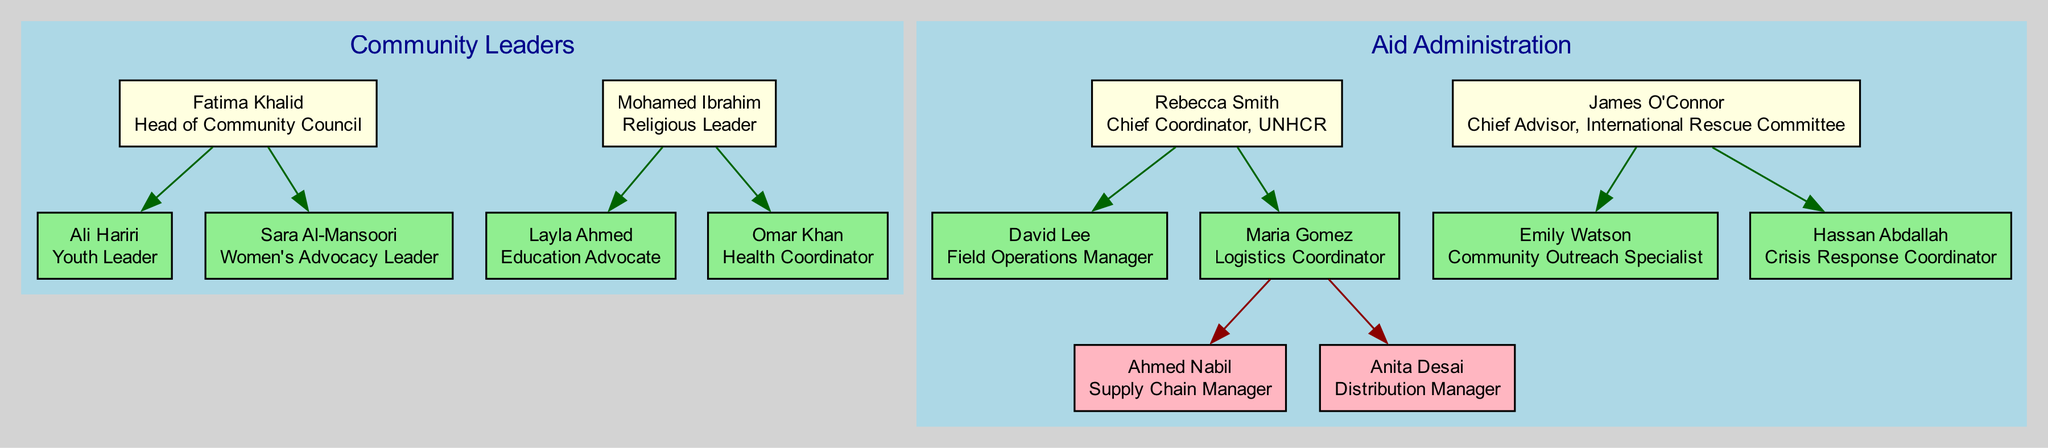What is the role of Fatima Khalid? According to the diagram, Fatima Khalid is identified as the "Head of Community Council." This is confirmed by locating her node, which contains her name and associated role.
Answer: Head of Community Council Who is the child of Mohamed Ibrahim? In the diagram, Mohamed Ibrahim has two direct subordinates indicated as his children: Layla Ahmed and Omar Khan. Any of these can be considered valid. Here, we can select one of the names as the answer.
Answer: Layla Ahmed How many grandchildren does Rebecca Smith have? The diagram indicates that Rebecca Smith has a direct subordinate, Maria Gomez, who has two subordinates: Ahmed Nabil and Anita Desai. Thus, Rebecca Smith has two grandchildren.
Answer: 2 Which community leader focuses on women's advocacy? From the diagram, Sara Al-Mansoori is specifically noted as the "Women's Advocacy Leader." Her node clearly states her focus.
Answer: Sara Al-Mansoori What is the relation between Ali Hariri and Fatima Khalid? The diagram shows that Ali Hariri is a direct child of Fatima Khalid, indicating a parent-child relationship. This can be verified by looking at Fatima's subordinates.
Answer: Child Which figure has the role of Logistics Coordinator? The diagram identifies Maria Gomez as the "Logistics Coordinator." This is found under the node of Rebecca Smith, who is her parent in the hierarchy.
Answer: Maria Gomez How many figures are listed under Aid Administration? In the Aid Administration category, there are two main figures identified: Rebecca Smith and James O'Connor. Counting these gives a total of two figures.
Answer: 2 Who is the Head of Community Council? The diagram illustrates that Fatima Khalid holds the title of Head of Community Council, evident from her node placement in the Community Leaders category.
Answer: Fatima Khalid Which child of Rebecca Smith is in charge of field operations? According to the diagram, David Lee is the "Field Operations Manager," and he is noted as a child of Rebecca Smith. This shows his direct association with her role.
Answer: David Lee 